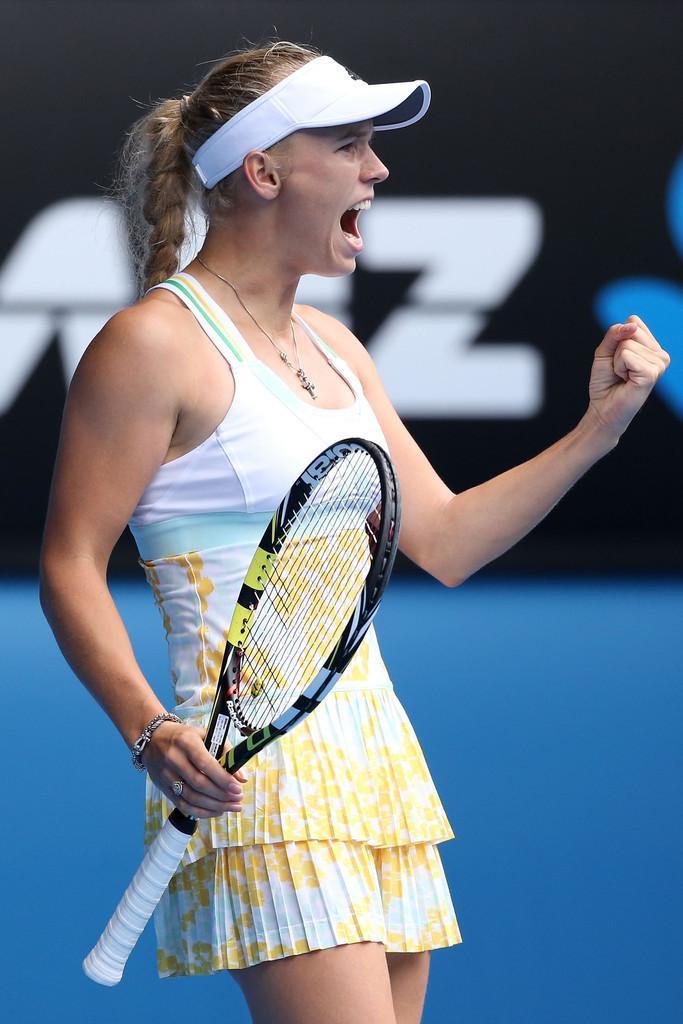Could you give a brief overview of what you see in this image? Here we can see a woman standing and screaming a loud,and holding a racket in her hands. 